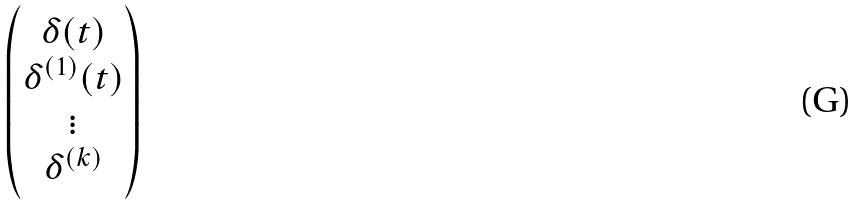Convert formula to latex. <formula><loc_0><loc_0><loc_500><loc_500>\begin{pmatrix} \delta ( t ) \\ \delta ^ { ( 1 ) } ( t ) \\ \vdots \\ \delta ^ { ( k ) } \end{pmatrix}</formula> 